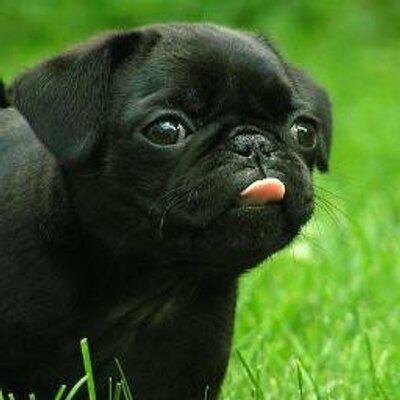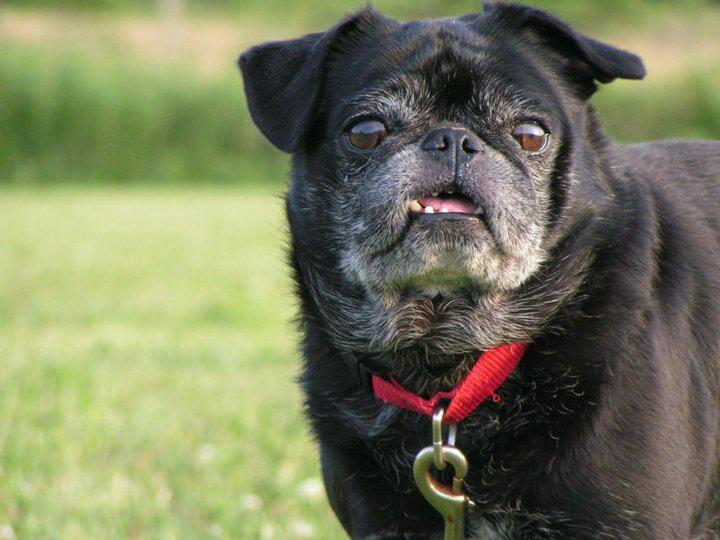The first image is the image on the left, the second image is the image on the right. Analyze the images presented: Is the assertion "There are two dogs in the image on the left." valid? Answer yes or no. No. 